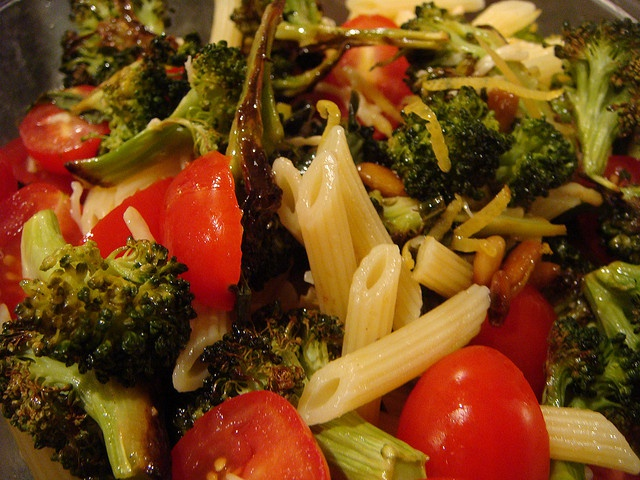Describe the objects in this image and their specific colors. I can see broccoli in black, olive, and maroon tones, broccoli in black, maroon, and olive tones, broccoli in black, olive, and maroon tones, broccoli in black, olive, and maroon tones, and broccoli in black, olive, and maroon tones in this image. 